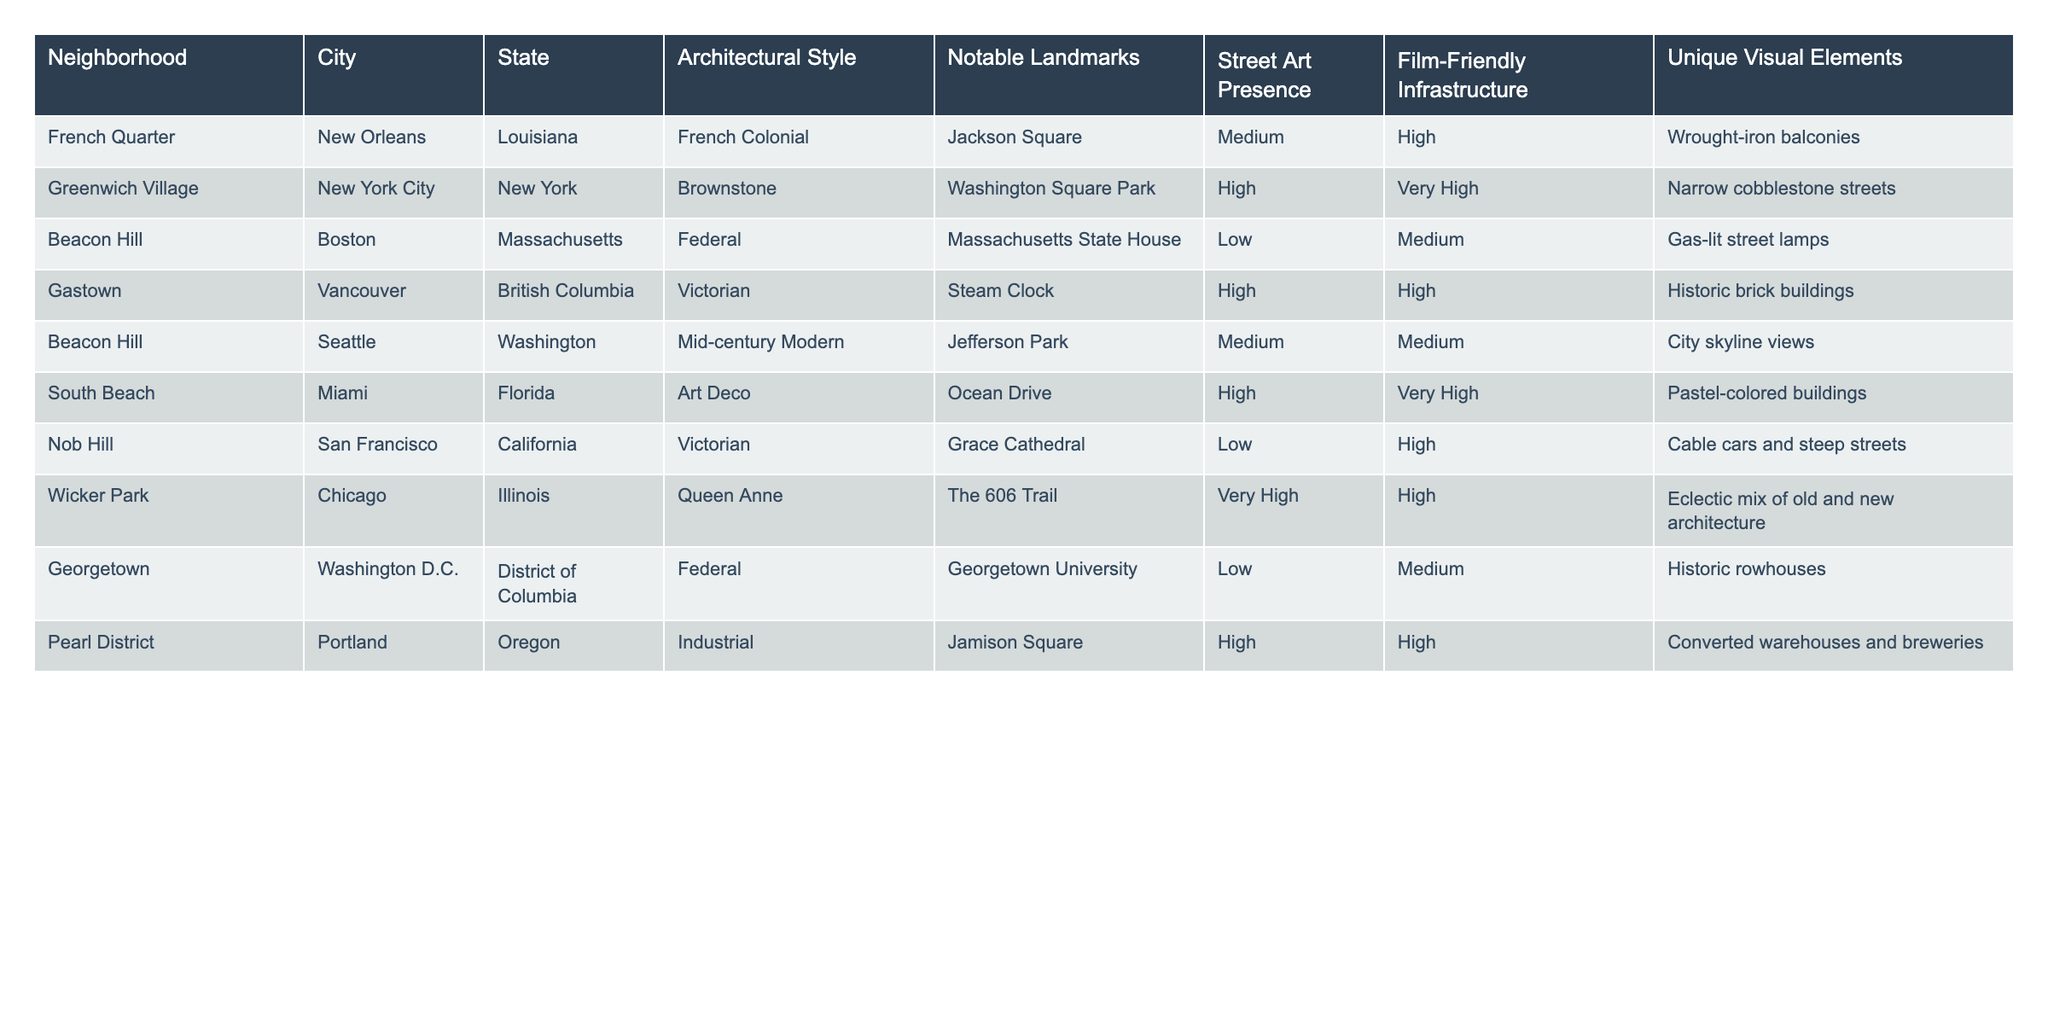What is the architectural style of South Beach? According to the table, South Beach is listed with the architectural style of Art Deco.
Answer: Art Deco Which neighborhood has the highest street art presence? Looking at the "Street Art Presence" column, Greenwich Village has a high level of street art presence, which is the highest ranking in the table.
Answer: Greenwich Village How many neighborhoods have a very high film-friendly infrastructure? The table shows that there are three neighborhoods with a "Very High" film-friendly infrastructure: Greenwich Village, South Beach, and Wicker Park.
Answer: 3 Is there a neighborhood in Boston listed, and if so, what is its name? Yes, the table shows that Beacon Hill is the listed neighborhood in Boston.
Answer: Beacon Hill Which neighborhood is associated with the notable landmark "Grace Cathedral"? The table indicates that Nob Hill is associated with the notable landmark Grace Cathedral.
Answer: Nob Hill What is the unique visual element of the Pearl District? According to the table, the unique visual element of the Pearl District includes converted warehouses and breweries.
Answer: Converted warehouses and breweries Among the neighborhoods listed, which one has the lowest street art presence? By checking the "Street Art Presence" column, it can be seen that Beacon Hill in Boston has a low street art presence, making it the lowest.
Answer: Beacon Hill Are there more neighborhoods with Victorian architectural style than those with Federal style? The table lists three neighborhoods with Victorian architectural style (Gastown, Nob Hill, and Beacon Hill in Seattle) and two with Federal style (Beacon Hill in Boston and Georgetown). Since three is greater than two, the answer is yes.
Answer: Yes How many neighborhoods in New Orleans and New York City are listed? The table lists one neighborhood from New Orleans (French Quarter) and one from New York City (Greenwich Village), totaling two neighborhoods.
Answer: 2 What is the only neighborhood in the table that has medium street art presence while also having medium film-friendly infrastructure? The table indicates that Beacon Hill in Seattle is the only neighborhood with both medium street art presence and medium film-friendly infrastructure.
Answer: Beacon Hill 